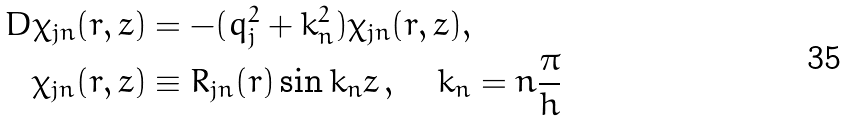Convert formula to latex. <formula><loc_0><loc_0><loc_500><loc_500>D \chi _ { j n } ( r , z ) & = - ( q _ { j } ^ { 2 } + k _ { n } ^ { 2 } ) \chi _ { j n } ( r , z ) , \\ \chi _ { j n } ( r , z ) & \equiv R _ { j n } ( r ) \sin k _ { n } z \, , \quad k _ { n } = n \frac { \pi } { h }</formula> 